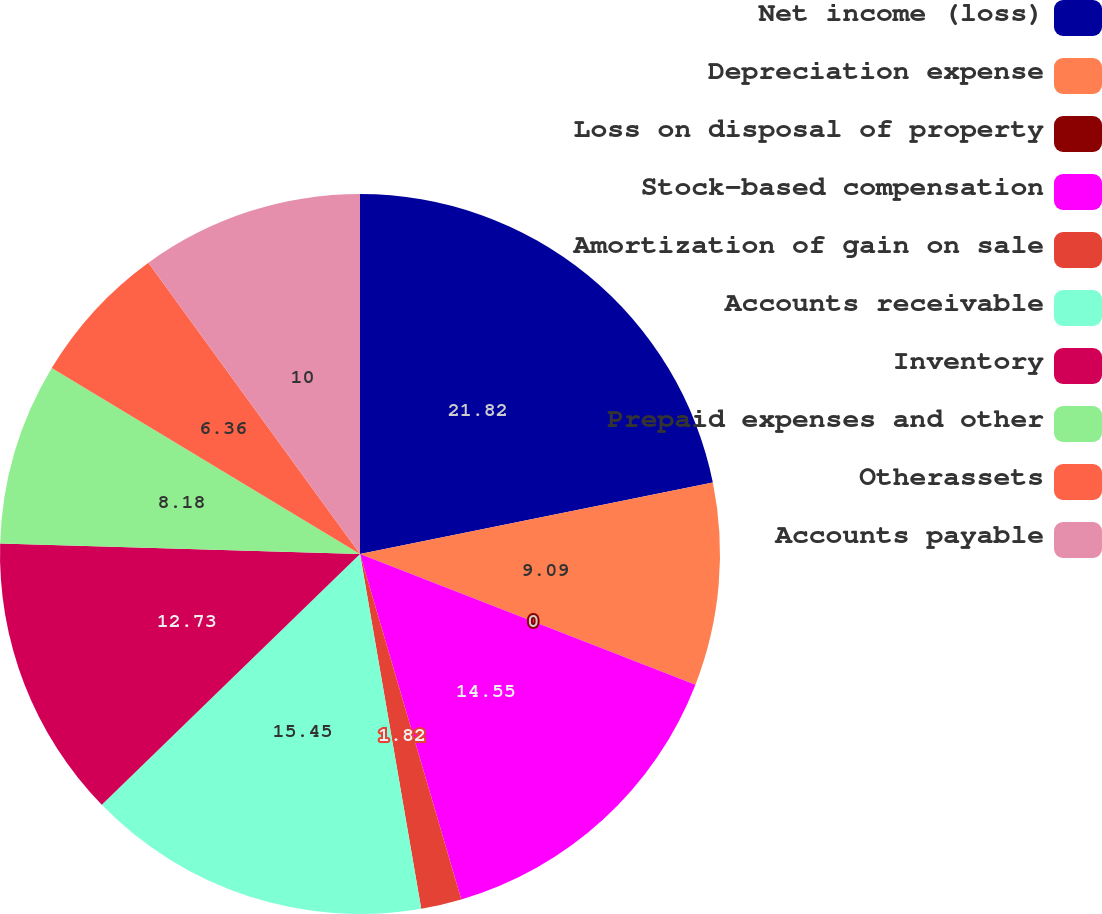Convert chart. <chart><loc_0><loc_0><loc_500><loc_500><pie_chart><fcel>Net income (loss)<fcel>Depreciation expense<fcel>Loss on disposal of property<fcel>Stock-based compensation<fcel>Amortization of gain on sale<fcel>Accounts receivable<fcel>Inventory<fcel>Prepaid expenses and other<fcel>Otherassets<fcel>Accounts payable<nl><fcel>21.82%<fcel>9.09%<fcel>0.0%<fcel>14.55%<fcel>1.82%<fcel>15.45%<fcel>12.73%<fcel>8.18%<fcel>6.36%<fcel>10.0%<nl></chart> 